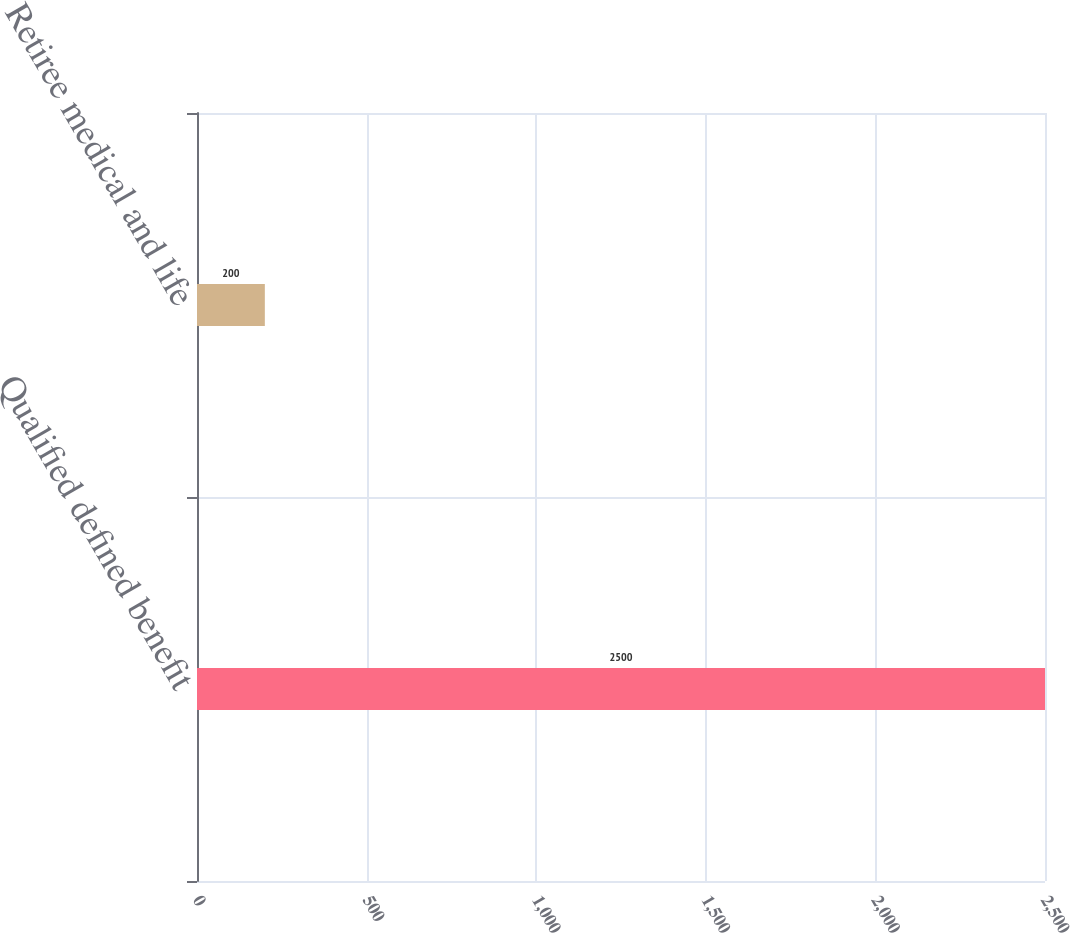<chart> <loc_0><loc_0><loc_500><loc_500><bar_chart><fcel>Qualified defined benefit<fcel>Retiree medical and life<nl><fcel>2500<fcel>200<nl></chart> 